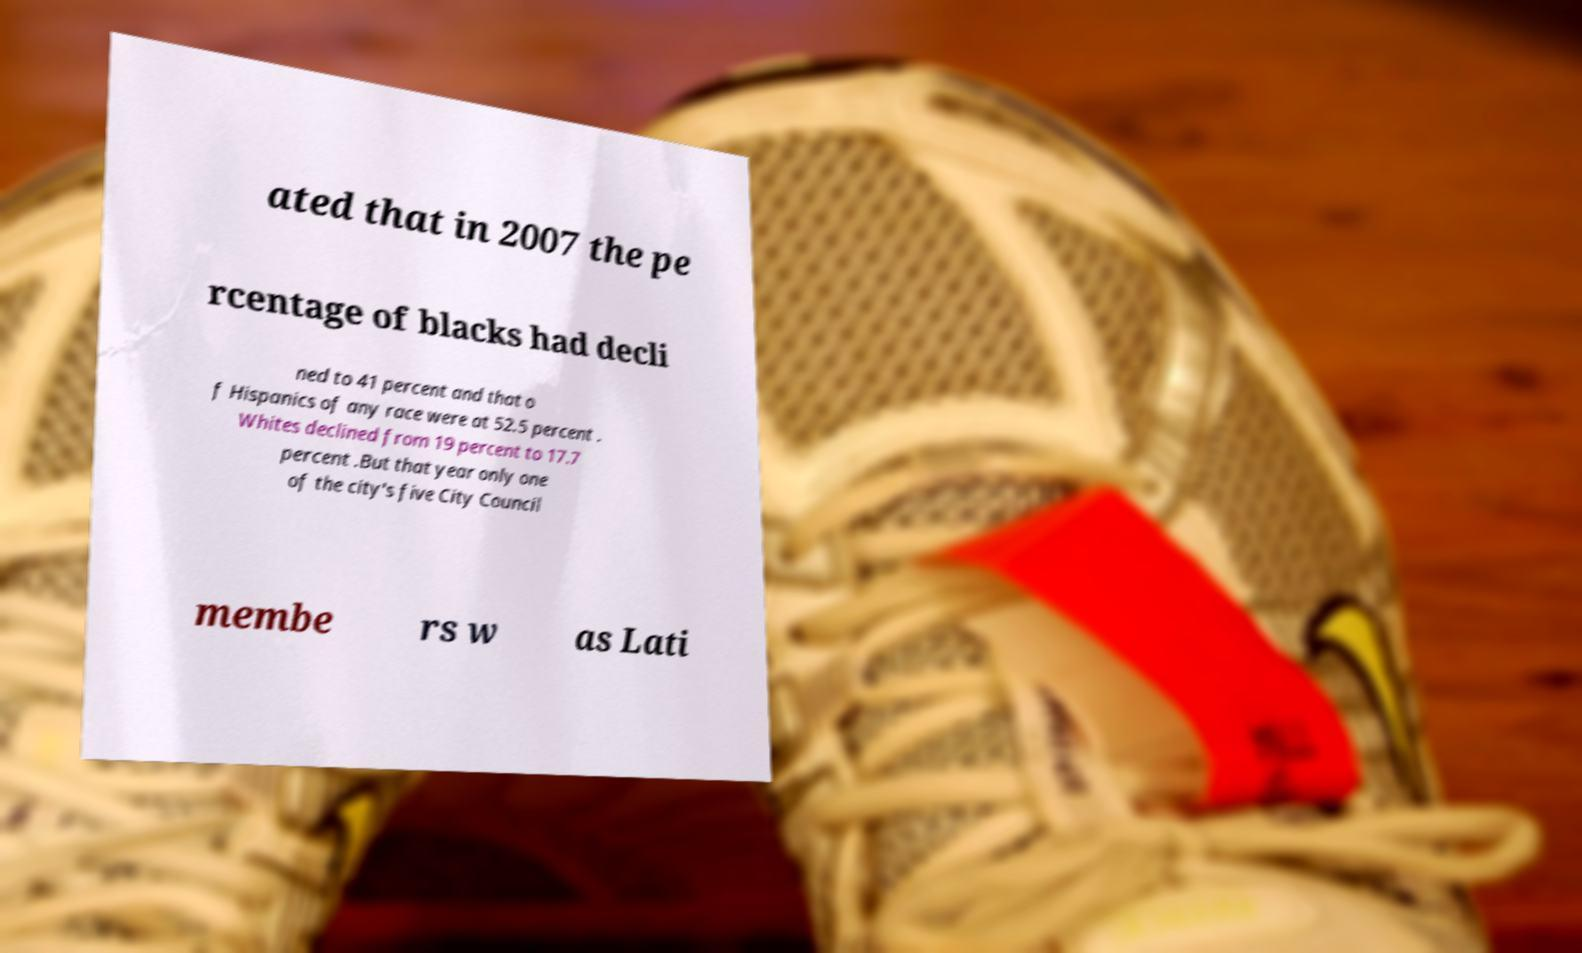Please read and relay the text visible in this image. What does it say? ated that in 2007 the pe rcentage of blacks had decli ned to 41 percent and that o f Hispanics of any race were at 52.5 percent . Whites declined from 19 percent to 17.7 percent .But that year only one of the city's five City Council membe rs w as Lati 